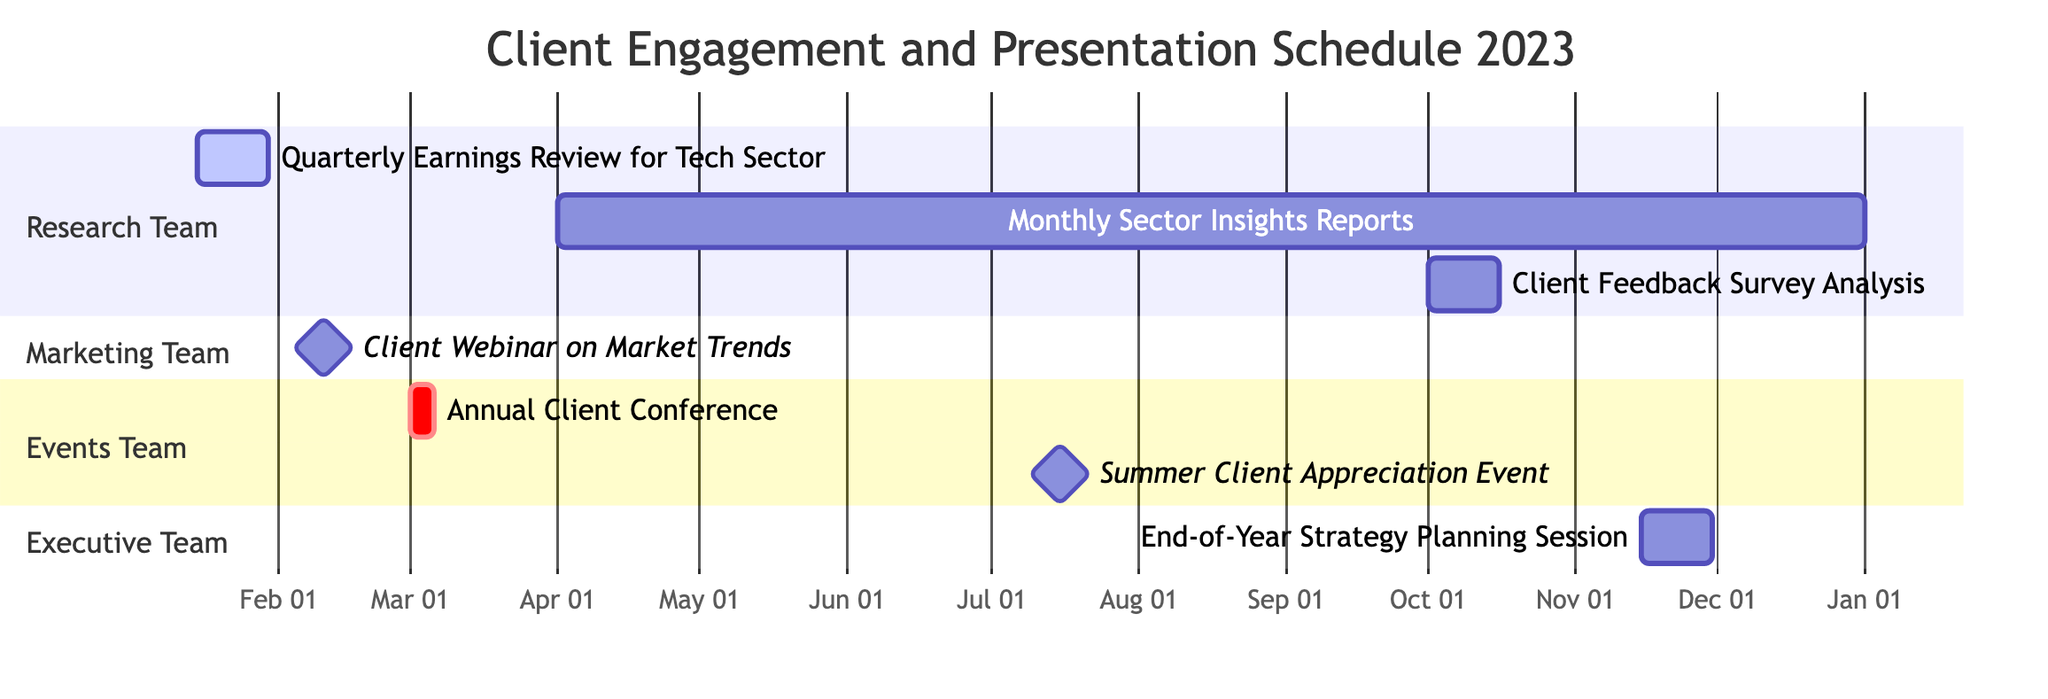What is the duration of the Quarterly Earnings Review for Tech Sector? The duration of the Quarterly Earnings Review for Tech Sector is provided in the diagram as "15 days." This information can be found in the section labeled "Research Team" next to the task.
Answer: 15 days Which team is responsible for the Client Feedback Survey Analysis? The team responsible for the Client Feedback Survey Analysis is explicitly mentioned in the diagram under that task. It is listed as the "Research Team."
Answer: Research Team How many tasks are scheduled for the Marketing Team? By inspecting the diagram, there is only one task labeled "Client Webinar on Market Trends" assigned to the Marketing Team, which means there is just one task for this team.
Answer: 1 What is the start date of the End-of-Year Strategy Planning Session? The start date for the End-of-Year Strategy Planning Session can be found in the respective section for the Executive Team, which indicates "2023-11-15" as the start date.
Answer: 2023-11-15 What is the earliest start date among all tasks in the chart? To find the earliest start date, we compare all start dates listed in the diagram. The earliest one is "2023-01-15" for the Quarterly Earnings Review for Tech Sector.
Answer: 2023-01-15 Which task overlaps with the duration of the Monthly Sector Insights Reports? The Monthly Sector Insights Reports run from April 1 to December 31, which overlaps with the Client Feedback Survey Analysis scheduled from October 1 to October 15. This can be seen by comparing the time frames visually.
Answer: Client Feedback Survey Analysis What is the length of the Monthly Sector Insights Reports duration in months? The diagram states that the Monthly Sector Insights Reports run for "9 months," which can directly be interpreted from the given information in the timeline.
Answer: 9 months Which event is marked as a milestone by the Events Team? Looking at the diagram, the task labeled "Summer Client Appreciation Event" is specifically identified as a milestone under the Events Team, indicating its significance.
Answer: Summer Client Appreciation Event 